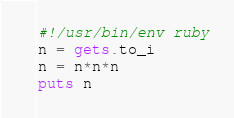<code> <loc_0><loc_0><loc_500><loc_500><_Ruby_>#!/usr/bin/env ruby
n = gets.to_i
n = n*n*n
puts n

</code> 